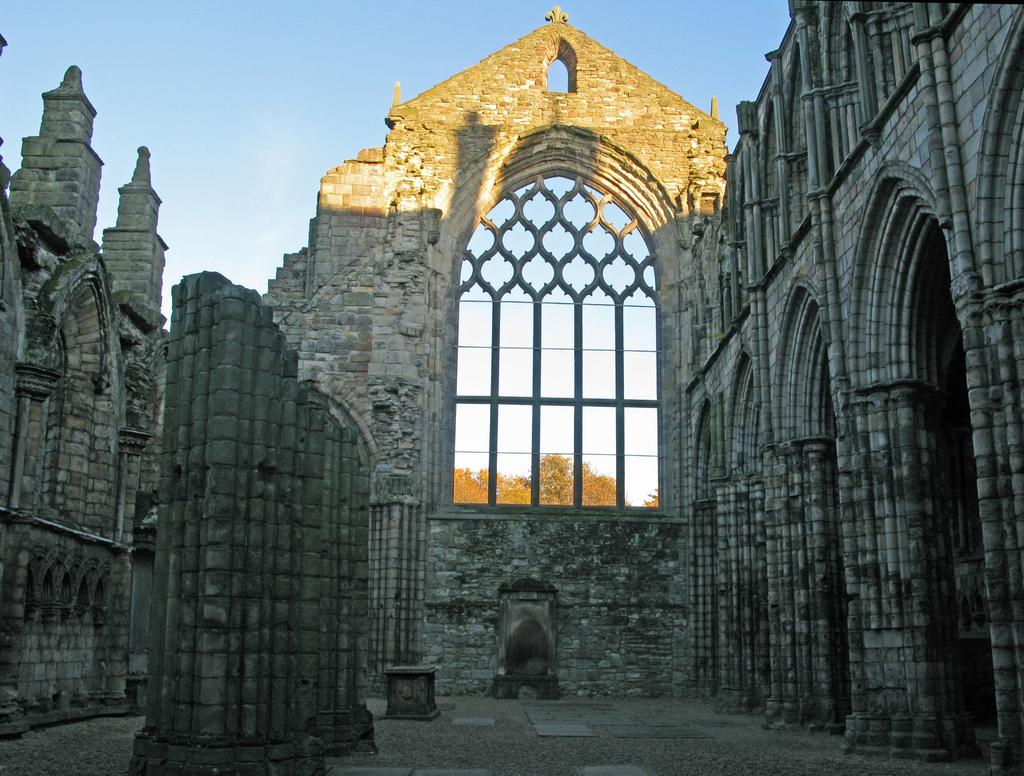What structure is present in the image? There is a building in the image. What type of natural vegetation can be seen in the background of the image? There are trees visible in the background of the image. What is the color of the sky in the image? The sky is blue and white in color. What type of silverware is being used during the dinner in the image? There is no dinner or silverware present in the image; it features a building and trees in the background. 